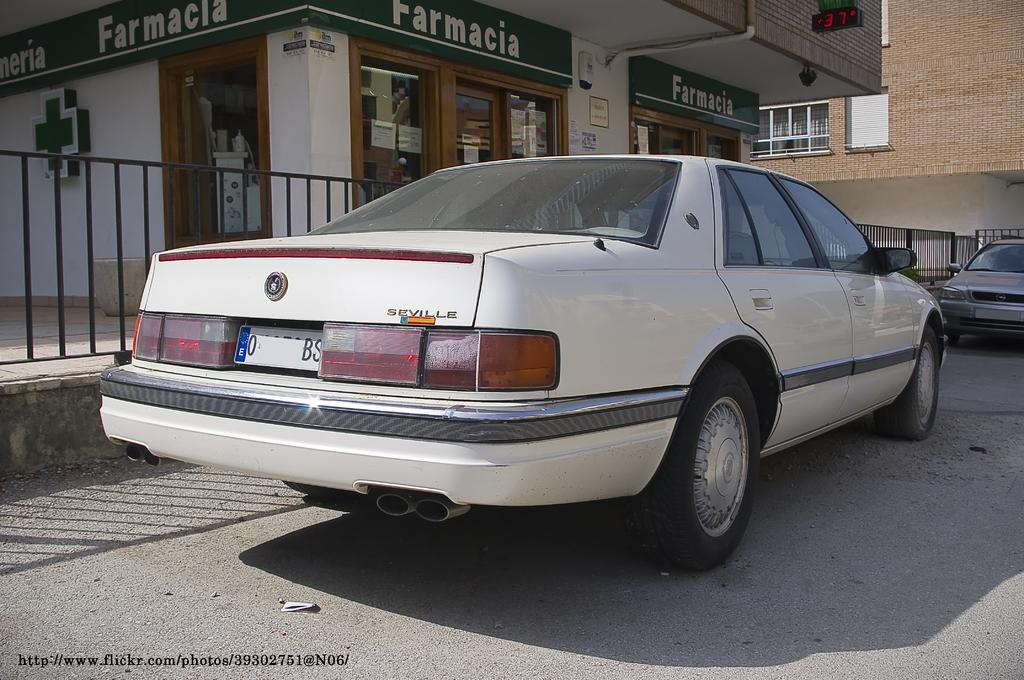What type of vehicle is on the road in the image? There is a white car on the road in the image. What is the condition of the other car in the image? There is a truncated car towards the right of the image. What type of establishment can be seen in the image? There is a medical store in the image. What kind of structure is present in the image? There is a building in the image. What type of decorative feature is visible in the image? There are grills in the image. What type of home is visible in the image? There is no home present in the image. Is there a jail visible in the image? There is no jail present in the image. 